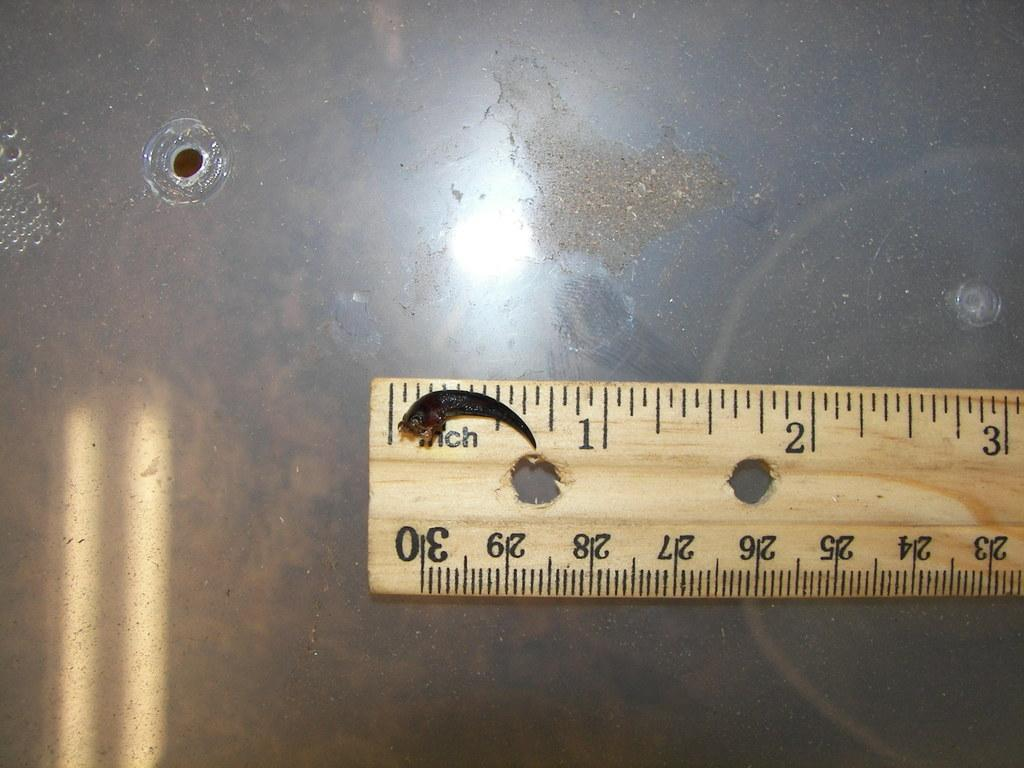<image>
Offer a succinct explanation of the picture presented. A bug is laying on the word inch on the ruler. 